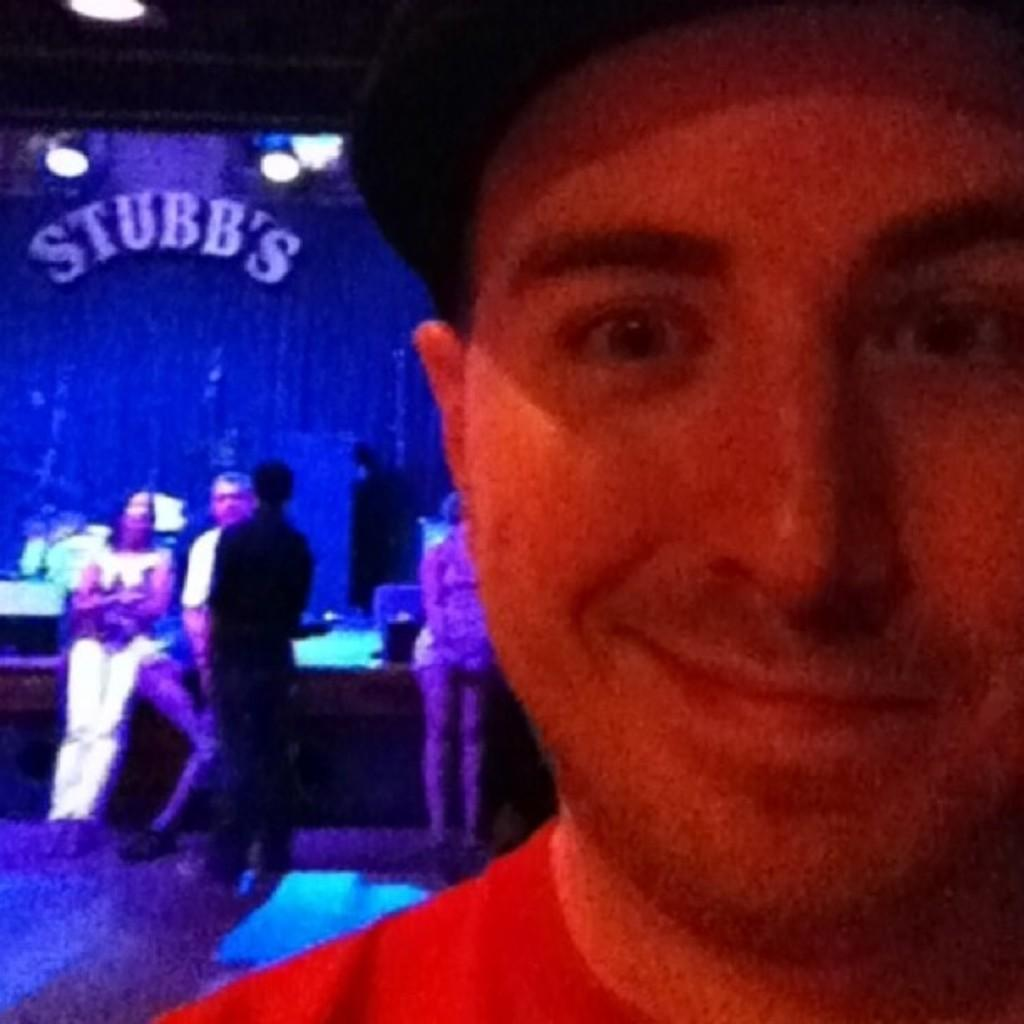What is the main subject of the image? There is a person in the image. Can you describe the surroundings of the person? There are other people in the background of the image. What can be seen in terms of lighting in the image? There are lights visible in the image. Is there any text present in the image? Yes, there is a word present in the image. How would you describe the background of the image? The background is blurred. How many girls are present in the image? There is no mention of girls in the provided facts, so we cannot determine their presence in the image. 